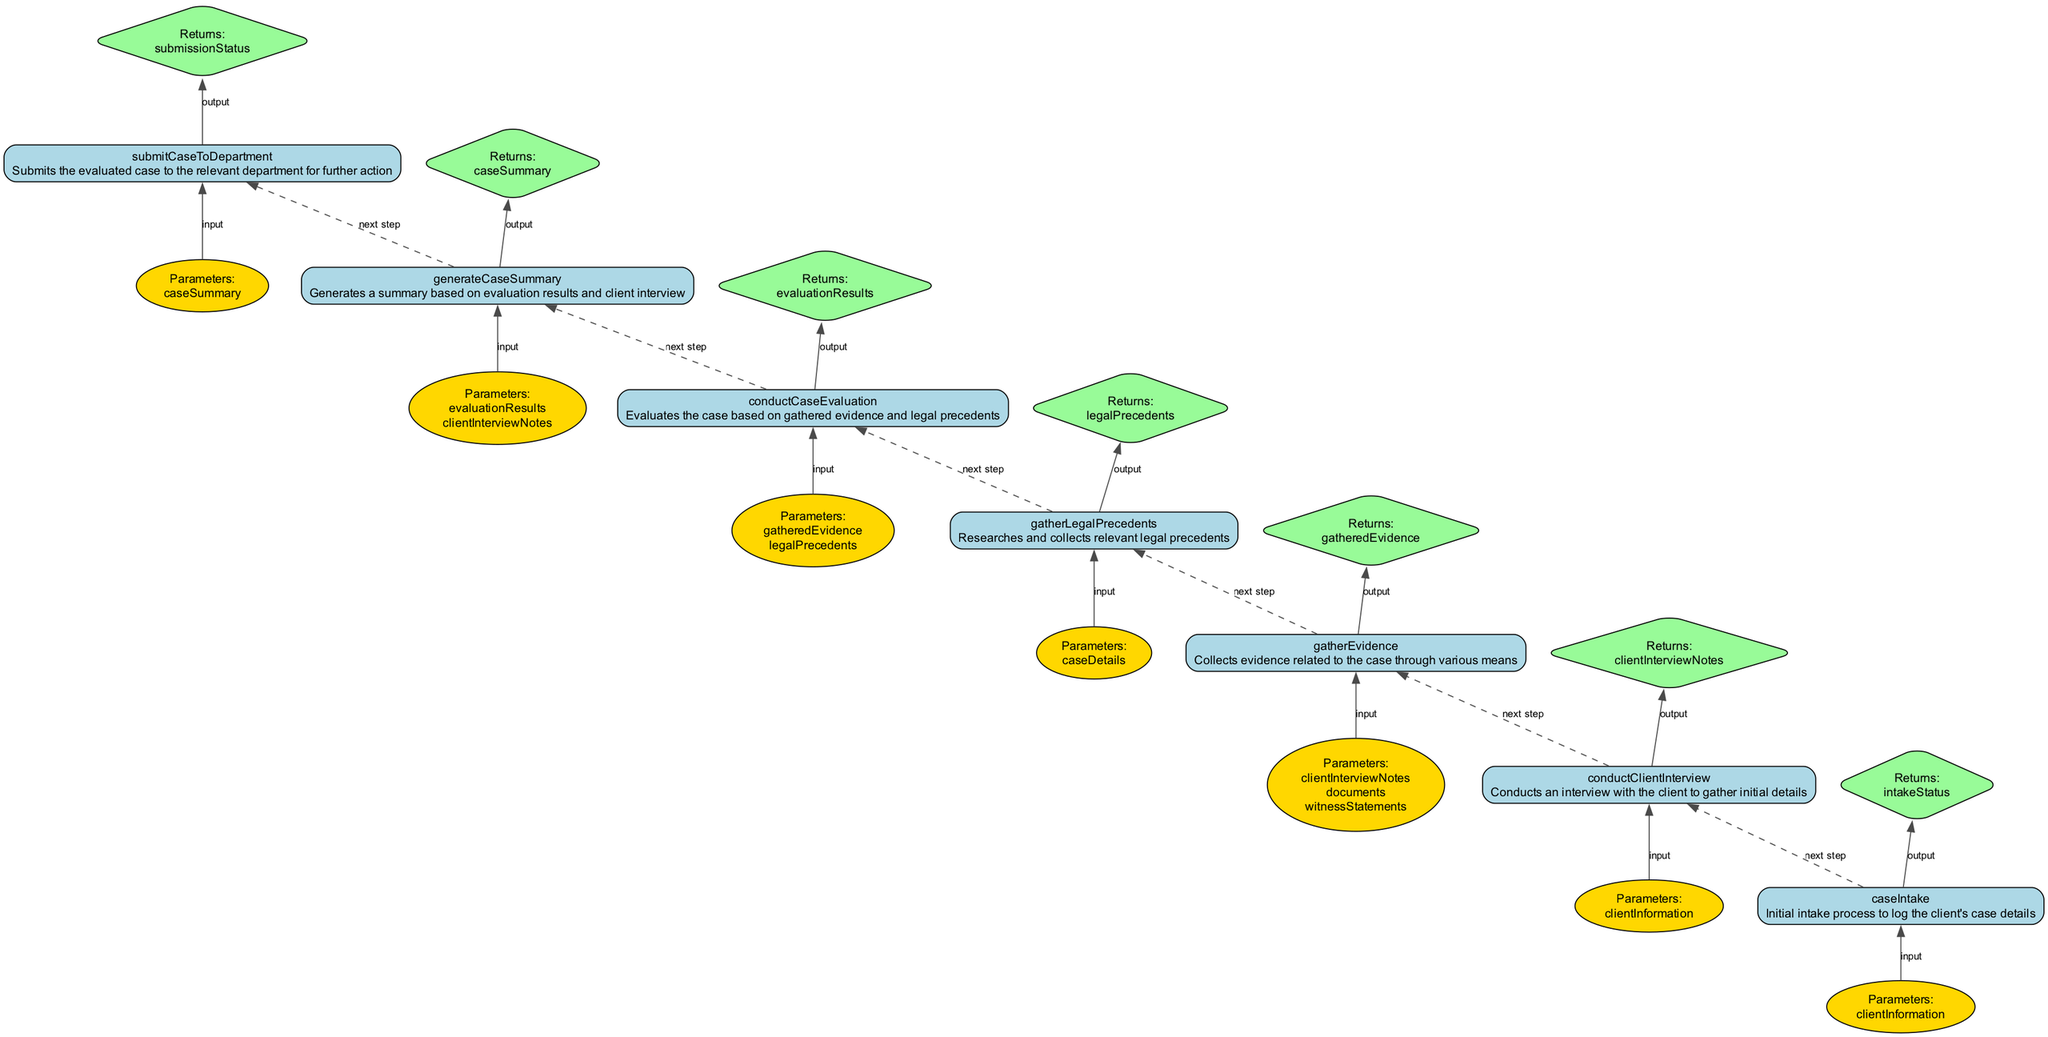What is the first step in the case intake process? The first step shown in the diagram is labeled "caseIntake", indicating that it is the initial intake process to log the client's case details.
Answer: caseIntake How many total functions are represented in the diagram? By counting all the nodes representing functions from the provided data, we can identify that there are a total of 7 functions depicted in the diagram.
Answer: 7 What is the output of the function "conductCaseEvaluation"? According to the diagram, the output for the function "conductCaseEvaluation" is labeled as "evaluationResults". This indicates what this function returns after processing its input parameters.
Answer: evaluationResults What follows "conductClientInterview" in the process flow? The diagram shows that after "conductClientInterview" is the next function "gatherEvidence", which represents the next step in the case intake and evaluation process.
Answer: gatherEvidence Which function generates a summary based on evaluation results? The diagram indicates that "generateCaseSummary" is the function responsible for creating a summary based on the evaluation results and client interview notes.
Answer: generateCaseSummary How many edges are present between the functions in the flowchart? By analyzing the connections between the nodes, there are 6 dashed edges connecting the subsequent functions in the flowchart that represents the steps in the case intake and evaluation process.
Answer: 6 What is the return value of the "submitCaseToDepartment" function? The return value for "submitCaseToDepartment" is labeled as "submissionStatus" in the diagram, indicating what this function produces upon completion.
Answer: submissionStatus What are the parameters needed for the function "gatherEvidence"? The diagram notes that the function "gatherEvidence" requires three parameters: "clientInterviewNotes", "documents", and "witnessStatements", which are essential for collecting relevant evidence related to the case.
Answer: clientInterviewNotes, documents, witnessStatements Which function relies on the output of "gatherLegalPrecedents"? By following the flow of the diagram, "conductCaseEvaluation" is dependent on the output from "gatherLegalPrecedents", meaning it needs to use the legal precedents gathered during its execution.
Answer: conductCaseEvaluation 